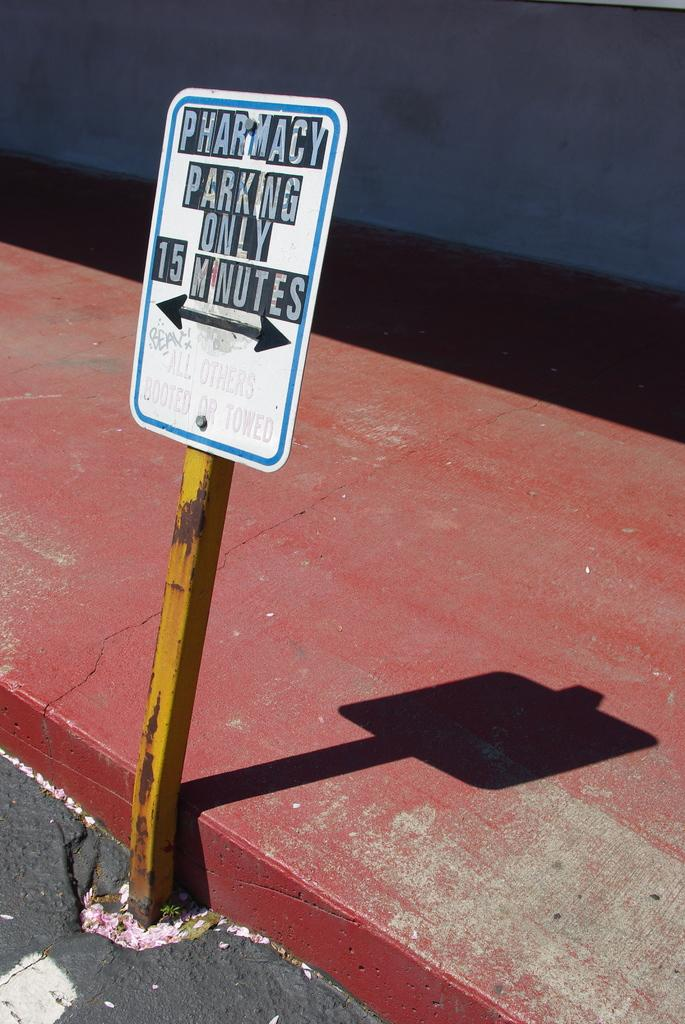<image>
Render a clear and concise summary of the photo. A sign designating the parking spot is only for pharmacy parking and only for fifteen minutes. 